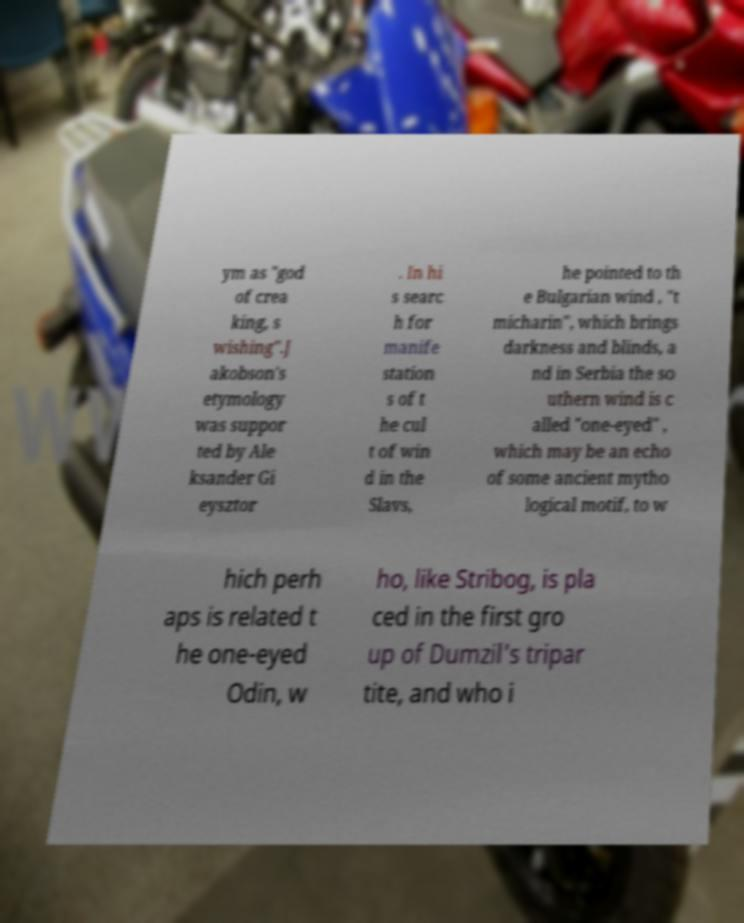Can you accurately transcribe the text from the provided image for me? ym as "god of crea king, s wishing".J akobson's etymology was suppor ted by Ale ksander Gi eysztor . In hi s searc h for manife station s of t he cul t of win d in the Slavs, he pointed to th e Bulgarian wind , "t micharin", which brings darkness and blinds, a nd in Serbia the so uthern wind is c alled "one-eyed" , which may be an echo of some ancient mytho logical motif, to w hich perh aps is related t he one-eyed Odin, w ho, like Stribog, is pla ced in the first gro up of Dumzil's tripar tite, and who i 